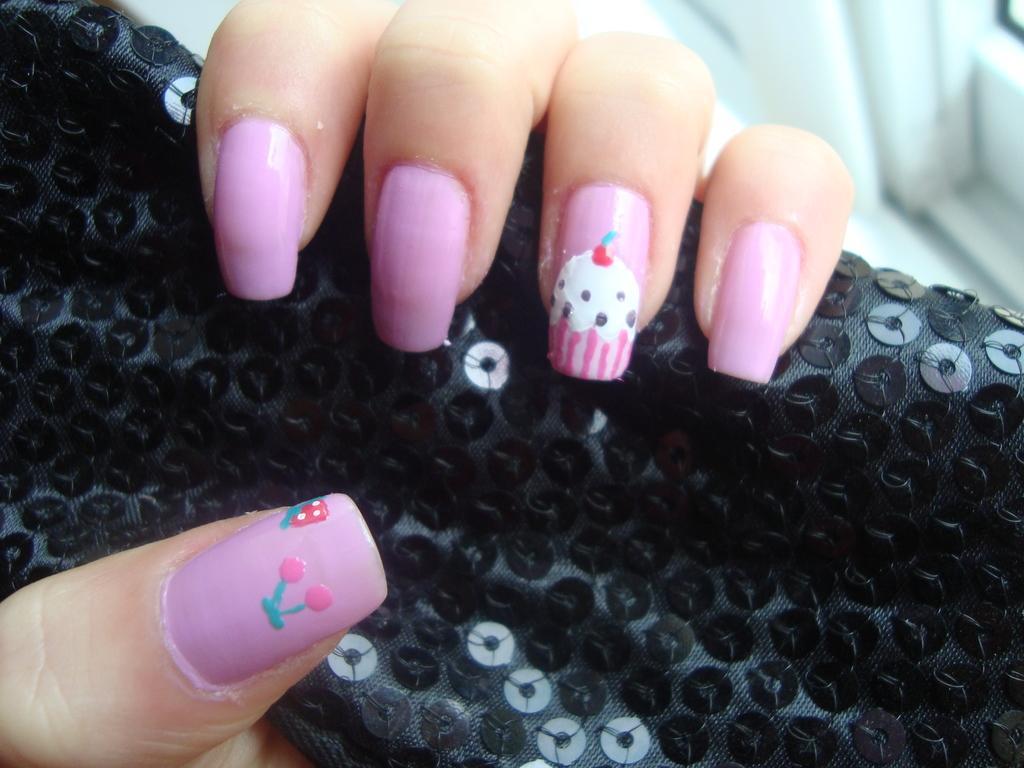In one or two sentences, can you explain what this image depicts? In this image we can see fingers of a person holding a black color object. On the nails we can see nail polish. 